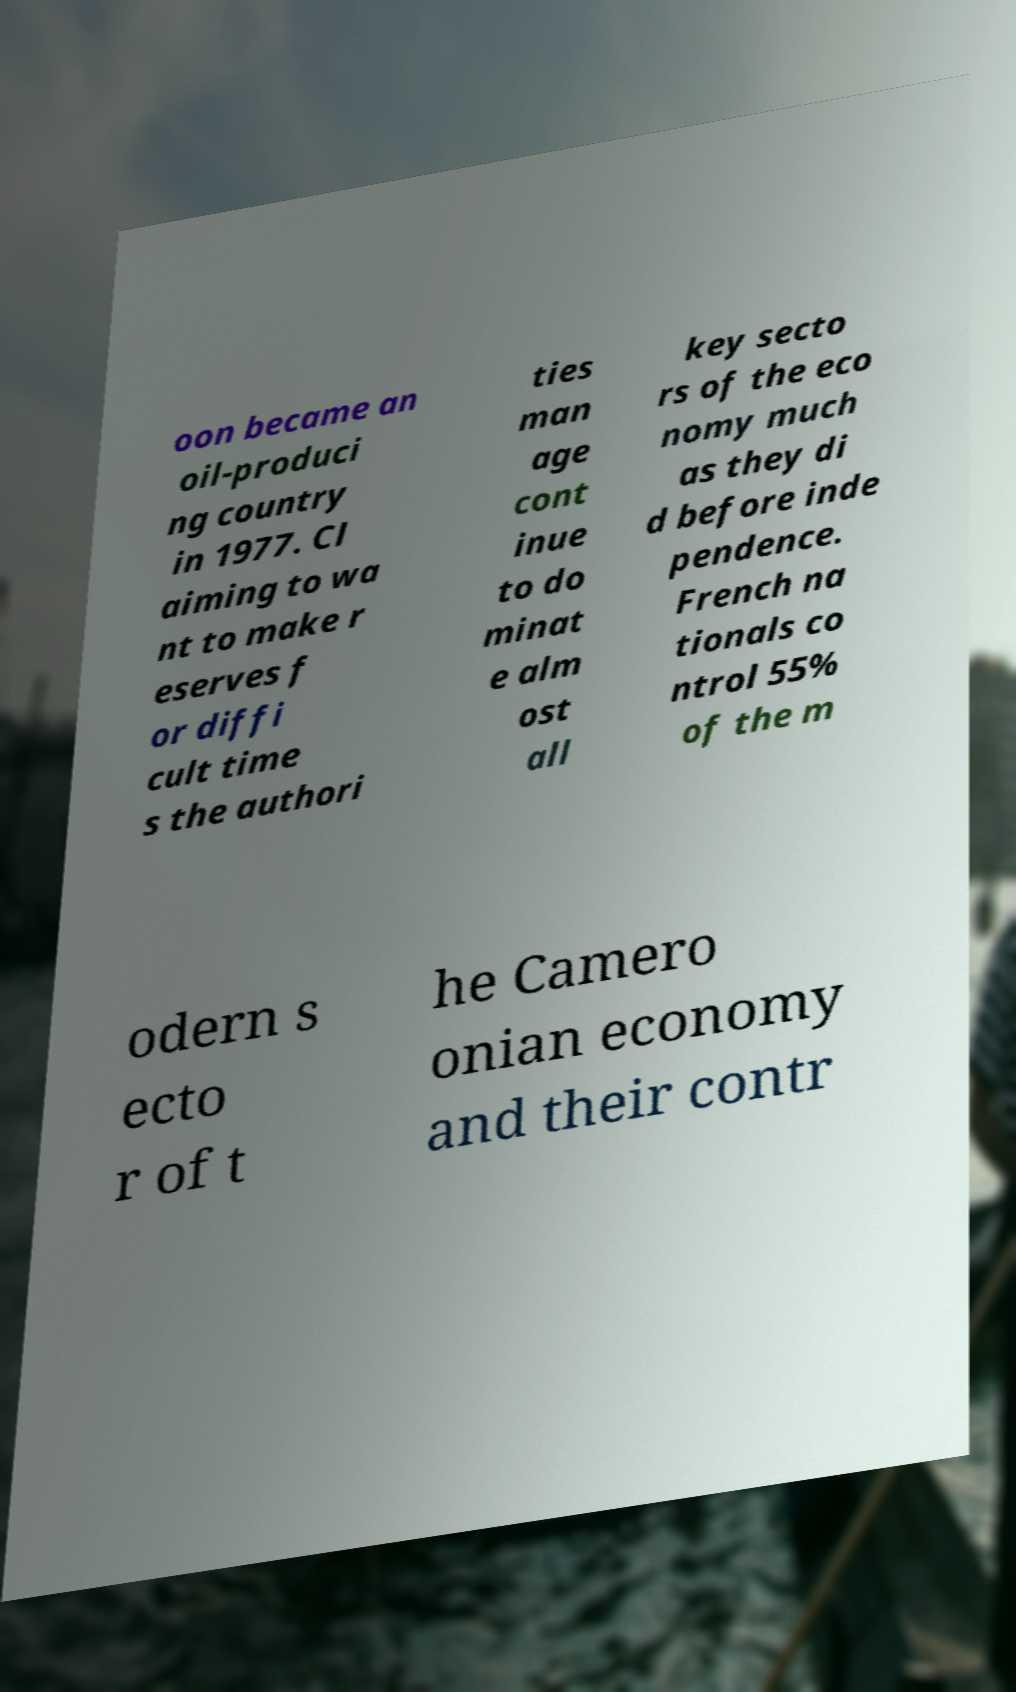There's text embedded in this image that I need extracted. Can you transcribe it verbatim? oon became an oil-produci ng country in 1977. Cl aiming to wa nt to make r eserves f or diffi cult time s the authori ties man age cont inue to do minat e alm ost all key secto rs of the eco nomy much as they di d before inde pendence. French na tionals co ntrol 55% of the m odern s ecto r of t he Camero onian economy and their contr 